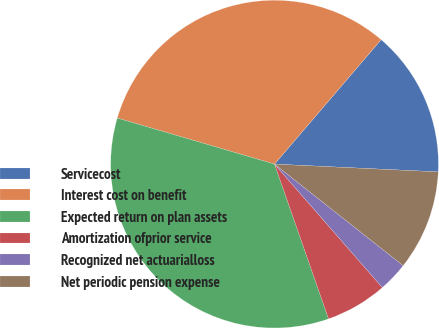Convert chart to OTSL. <chart><loc_0><loc_0><loc_500><loc_500><pie_chart><fcel>Servicecost<fcel>Interest cost on benefit<fcel>Expected return on plan assets<fcel>Amortization ofprior service<fcel>Recognized net actuarialloss<fcel>Net periodic pension expense<nl><fcel>14.48%<fcel>31.74%<fcel>34.88%<fcel>6.08%<fcel>2.94%<fcel>9.88%<nl></chart> 